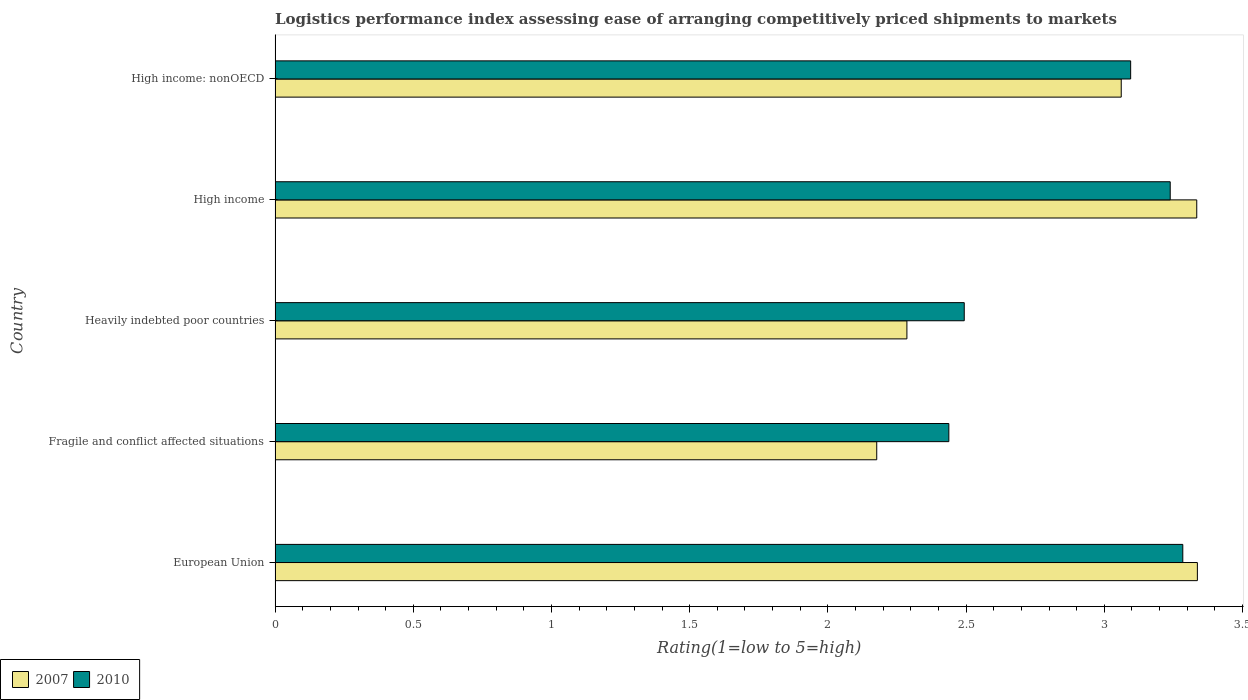How many groups of bars are there?
Your answer should be very brief. 5. Are the number of bars on each tick of the Y-axis equal?
Offer a terse response. Yes. How many bars are there on the 4th tick from the top?
Ensure brevity in your answer.  2. What is the label of the 3rd group of bars from the top?
Provide a short and direct response. Heavily indebted poor countries. What is the Logistic performance index in 2010 in High income?
Offer a very short reply. 3.24. Across all countries, what is the maximum Logistic performance index in 2010?
Give a very brief answer. 3.28. Across all countries, what is the minimum Logistic performance index in 2007?
Ensure brevity in your answer.  2.18. In which country was the Logistic performance index in 2010 maximum?
Provide a short and direct response. European Union. In which country was the Logistic performance index in 2010 minimum?
Provide a short and direct response. Fragile and conflict affected situations. What is the total Logistic performance index in 2010 in the graph?
Ensure brevity in your answer.  14.55. What is the difference between the Logistic performance index in 2007 in European Union and that in Heavily indebted poor countries?
Offer a terse response. 1.05. What is the difference between the Logistic performance index in 2007 in Heavily indebted poor countries and the Logistic performance index in 2010 in Fragile and conflict affected situations?
Provide a succinct answer. -0.15. What is the average Logistic performance index in 2007 per country?
Your answer should be compact. 2.84. What is the difference between the Logistic performance index in 2010 and Logistic performance index in 2007 in High income?
Ensure brevity in your answer.  -0.1. What is the ratio of the Logistic performance index in 2010 in European Union to that in High income: nonOECD?
Your answer should be compact. 1.06. Is the difference between the Logistic performance index in 2010 in Fragile and conflict affected situations and High income greater than the difference between the Logistic performance index in 2007 in Fragile and conflict affected situations and High income?
Offer a terse response. Yes. What is the difference between the highest and the second highest Logistic performance index in 2010?
Keep it short and to the point. 0.05. What is the difference between the highest and the lowest Logistic performance index in 2007?
Provide a succinct answer. 1.16. In how many countries, is the Logistic performance index in 2010 greater than the average Logistic performance index in 2010 taken over all countries?
Provide a short and direct response. 3. Is the sum of the Logistic performance index in 2007 in European Union and High income: nonOECD greater than the maximum Logistic performance index in 2010 across all countries?
Your response must be concise. Yes. How many bars are there?
Offer a terse response. 10. Are all the bars in the graph horizontal?
Your response must be concise. Yes. What is the difference between two consecutive major ticks on the X-axis?
Your response must be concise. 0.5. Does the graph contain any zero values?
Provide a short and direct response. No. Does the graph contain grids?
Your answer should be compact. No. How are the legend labels stacked?
Your answer should be compact. Horizontal. What is the title of the graph?
Provide a succinct answer. Logistics performance index assessing ease of arranging competitively priced shipments to markets. Does "1972" appear as one of the legend labels in the graph?
Offer a terse response. No. What is the label or title of the X-axis?
Ensure brevity in your answer.  Rating(1=low to 5=high). What is the Rating(1=low to 5=high) in 2007 in European Union?
Make the answer very short. 3.34. What is the Rating(1=low to 5=high) of 2010 in European Union?
Your answer should be very brief. 3.28. What is the Rating(1=low to 5=high) in 2007 in Fragile and conflict affected situations?
Your response must be concise. 2.18. What is the Rating(1=low to 5=high) of 2010 in Fragile and conflict affected situations?
Offer a very short reply. 2.44. What is the Rating(1=low to 5=high) of 2007 in Heavily indebted poor countries?
Make the answer very short. 2.29. What is the Rating(1=low to 5=high) in 2010 in Heavily indebted poor countries?
Provide a succinct answer. 2.49. What is the Rating(1=low to 5=high) of 2007 in High income?
Keep it short and to the point. 3.33. What is the Rating(1=low to 5=high) in 2010 in High income?
Provide a short and direct response. 3.24. What is the Rating(1=low to 5=high) of 2007 in High income: nonOECD?
Your answer should be very brief. 3.06. What is the Rating(1=low to 5=high) in 2010 in High income: nonOECD?
Your response must be concise. 3.1. Across all countries, what is the maximum Rating(1=low to 5=high) of 2007?
Give a very brief answer. 3.34. Across all countries, what is the maximum Rating(1=low to 5=high) in 2010?
Ensure brevity in your answer.  3.28. Across all countries, what is the minimum Rating(1=low to 5=high) in 2007?
Provide a succinct answer. 2.18. Across all countries, what is the minimum Rating(1=low to 5=high) in 2010?
Provide a succinct answer. 2.44. What is the total Rating(1=low to 5=high) in 2007 in the graph?
Ensure brevity in your answer.  14.19. What is the total Rating(1=low to 5=high) in 2010 in the graph?
Provide a short and direct response. 14.55. What is the difference between the Rating(1=low to 5=high) in 2007 in European Union and that in Fragile and conflict affected situations?
Keep it short and to the point. 1.16. What is the difference between the Rating(1=low to 5=high) in 2010 in European Union and that in Fragile and conflict affected situations?
Offer a terse response. 0.85. What is the difference between the Rating(1=low to 5=high) in 2007 in European Union and that in Heavily indebted poor countries?
Provide a succinct answer. 1.05. What is the difference between the Rating(1=low to 5=high) in 2010 in European Union and that in Heavily indebted poor countries?
Your answer should be very brief. 0.79. What is the difference between the Rating(1=low to 5=high) of 2007 in European Union and that in High income?
Offer a very short reply. 0. What is the difference between the Rating(1=low to 5=high) of 2010 in European Union and that in High income?
Make the answer very short. 0.05. What is the difference between the Rating(1=low to 5=high) of 2007 in European Union and that in High income: nonOECD?
Provide a short and direct response. 0.28. What is the difference between the Rating(1=low to 5=high) of 2010 in European Union and that in High income: nonOECD?
Offer a terse response. 0.19. What is the difference between the Rating(1=low to 5=high) of 2007 in Fragile and conflict affected situations and that in Heavily indebted poor countries?
Keep it short and to the point. -0.11. What is the difference between the Rating(1=low to 5=high) in 2010 in Fragile and conflict affected situations and that in Heavily indebted poor countries?
Offer a terse response. -0.06. What is the difference between the Rating(1=low to 5=high) in 2007 in Fragile and conflict affected situations and that in High income?
Your answer should be very brief. -1.16. What is the difference between the Rating(1=low to 5=high) of 2010 in Fragile and conflict affected situations and that in High income?
Your answer should be very brief. -0.8. What is the difference between the Rating(1=low to 5=high) of 2007 in Fragile and conflict affected situations and that in High income: nonOECD?
Your answer should be very brief. -0.88. What is the difference between the Rating(1=low to 5=high) in 2010 in Fragile and conflict affected situations and that in High income: nonOECD?
Give a very brief answer. -0.66. What is the difference between the Rating(1=low to 5=high) of 2007 in Heavily indebted poor countries and that in High income?
Ensure brevity in your answer.  -1.05. What is the difference between the Rating(1=low to 5=high) of 2010 in Heavily indebted poor countries and that in High income?
Your answer should be very brief. -0.75. What is the difference between the Rating(1=low to 5=high) in 2007 in Heavily indebted poor countries and that in High income: nonOECD?
Offer a terse response. -0.78. What is the difference between the Rating(1=low to 5=high) of 2010 in Heavily indebted poor countries and that in High income: nonOECD?
Keep it short and to the point. -0.6. What is the difference between the Rating(1=low to 5=high) in 2007 in High income and that in High income: nonOECD?
Your response must be concise. 0.27. What is the difference between the Rating(1=low to 5=high) of 2010 in High income and that in High income: nonOECD?
Your response must be concise. 0.14. What is the difference between the Rating(1=low to 5=high) in 2007 in European Union and the Rating(1=low to 5=high) in 2010 in Fragile and conflict affected situations?
Keep it short and to the point. 0.9. What is the difference between the Rating(1=low to 5=high) in 2007 in European Union and the Rating(1=low to 5=high) in 2010 in Heavily indebted poor countries?
Your answer should be compact. 0.84. What is the difference between the Rating(1=low to 5=high) in 2007 in European Union and the Rating(1=low to 5=high) in 2010 in High income?
Ensure brevity in your answer.  0.1. What is the difference between the Rating(1=low to 5=high) of 2007 in European Union and the Rating(1=low to 5=high) of 2010 in High income: nonOECD?
Offer a very short reply. 0.24. What is the difference between the Rating(1=low to 5=high) of 2007 in Fragile and conflict affected situations and the Rating(1=low to 5=high) of 2010 in Heavily indebted poor countries?
Your answer should be very brief. -0.32. What is the difference between the Rating(1=low to 5=high) of 2007 in Fragile and conflict affected situations and the Rating(1=low to 5=high) of 2010 in High income?
Your response must be concise. -1.06. What is the difference between the Rating(1=low to 5=high) of 2007 in Fragile and conflict affected situations and the Rating(1=low to 5=high) of 2010 in High income: nonOECD?
Provide a short and direct response. -0.92. What is the difference between the Rating(1=low to 5=high) of 2007 in Heavily indebted poor countries and the Rating(1=low to 5=high) of 2010 in High income?
Ensure brevity in your answer.  -0.95. What is the difference between the Rating(1=low to 5=high) of 2007 in Heavily indebted poor countries and the Rating(1=low to 5=high) of 2010 in High income: nonOECD?
Provide a short and direct response. -0.81. What is the difference between the Rating(1=low to 5=high) of 2007 in High income and the Rating(1=low to 5=high) of 2010 in High income: nonOECD?
Make the answer very short. 0.24. What is the average Rating(1=low to 5=high) of 2007 per country?
Keep it short and to the point. 2.84. What is the average Rating(1=low to 5=high) in 2010 per country?
Offer a terse response. 2.91. What is the difference between the Rating(1=low to 5=high) of 2007 and Rating(1=low to 5=high) of 2010 in European Union?
Your answer should be compact. 0.05. What is the difference between the Rating(1=low to 5=high) of 2007 and Rating(1=low to 5=high) of 2010 in Fragile and conflict affected situations?
Provide a succinct answer. -0.26. What is the difference between the Rating(1=low to 5=high) of 2007 and Rating(1=low to 5=high) of 2010 in Heavily indebted poor countries?
Keep it short and to the point. -0.21. What is the difference between the Rating(1=low to 5=high) in 2007 and Rating(1=low to 5=high) in 2010 in High income?
Give a very brief answer. 0.1. What is the difference between the Rating(1=low to 5=high) of 2007 and Rating(1=low to 5=high) of 2010 in High income: nonOECD?
Your answer should be compact. -0.03. What is the ratio of the Rating(1=low to 5=high) of 2007 in European Union to that in Fragile and conflict affected situations?
Keep it short and to the point. 1.53. What is the ratio of the Rating(1=low to 5=high) of 2010 in European Union to that in Fragile and conflict affected situations?
Offer a terse response. 1.35. What is the ratio of the Rating(1=low to 5=high) in 2007 in European Union to that in Heavily indebted poor countries?
Provide a succinct answer. 1.46. What is the ratio of the Rating(1=low to 5=high) in 2010 in European Union to that in Heavily indebted poor countries?
Offer a terse response. 1.32. What is the ratio of the Rating(1=low to 5=high) in 2007 in European Union to that in High income?
Give a very brief answer. 1. What is the ratio of the Rating(1=low to 5=high) of 2007 in European Union to that in High income: nonOECD?
Make the answer very short. 1.09. What is the ratio of the Rating(1=low to 5=high) in 2010 in European Union to that in High income: nonOECD?
Your response must be concise. 1.06. What is the ratio of the Rating(1=low to 5=high) in 2007 in Fragile and conflict affected situations to that in Heavily indebted poor countries?
Your answer should be compact. 0.95. What is the ratio of the Rating(1=low to 5=high) of 2010 in Fragile and conflict affected situations to that in Heavily indebted poor countries?
Provide a short and direct response. 0.98. What is the ratio of the Rating(1=low to 5=high) of 2007 in Fragile and conflict affected situations to that in High income?
Provide a short and direct response. 0.65. What is the ratio of the Rating(1=low to 5=high) of 2010 in Fragile and conflict affected situations to that in High income?
Your answer should be compact. 0.75. What is the ratio of the Rating(1=low to 5=high) of 2007 in Fragile and conflict affected situations to that in High income: nonOECD?
Provide a succinct answer. 0.71. What is the ratio of the Rating(1=low to 5=high) of 2010 in Fragile and conflict affected situations to that in High income: nonOECD?
Keep it short and to the point. 0.79. What is the ratio of the Rating(1=low to 5=high) of 2007 in Heavily indebted poor countries to that in High income?
Provide a succinct answer. 0.69. What is the ratio of the Rating(1=low to 5=high) of 2010 in Heavily indebted poor countries to that in High income?
Offer a very short reply. 0.77. What is the ratio of the Rating(1=low to 5=high) of 2007 in Heavily indebted poor countries to that in High income: nonOECD?
Provide a succinct answer. 0.75. What is the ratio of the Rating(1=low to 5=high) in 2010 in Heavily indebted poor countries to that in High income: nonOECD?
Provide a short and direct response. 0.81. What is the ratio of the Rating(1=low to 5=high) of 2007 in High income to that in High income: nonOECD?
Your response must be concise. 1.09. What is the ratio of the Rating(1=low to 5=high) in 2010 in High income to that in High income: nonOECD?
Make the answer very short. 1.05. What is the difference between the highest and the second highest Rating(1=low to 5=high) of 2007?
Keep it short and to the point. 0. What is the difference between the highest and the second highest Rating(1=low to 5=high) of 2010?
Provide a short and direct response. 0.05. What is the difference between the highest and the lowest Rating(1=low to 5=high) in 2007?
Ensure brevity in your answer.  1.16. What is the difference between the highest and the lowest Rating(1=low to 5=high) of 2010?
Ensure brevity in your answer.  0.85. 